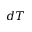Convert formula to latex. <formula><loc_0><loc_0><loc_500><loc_500>d T</formula> 